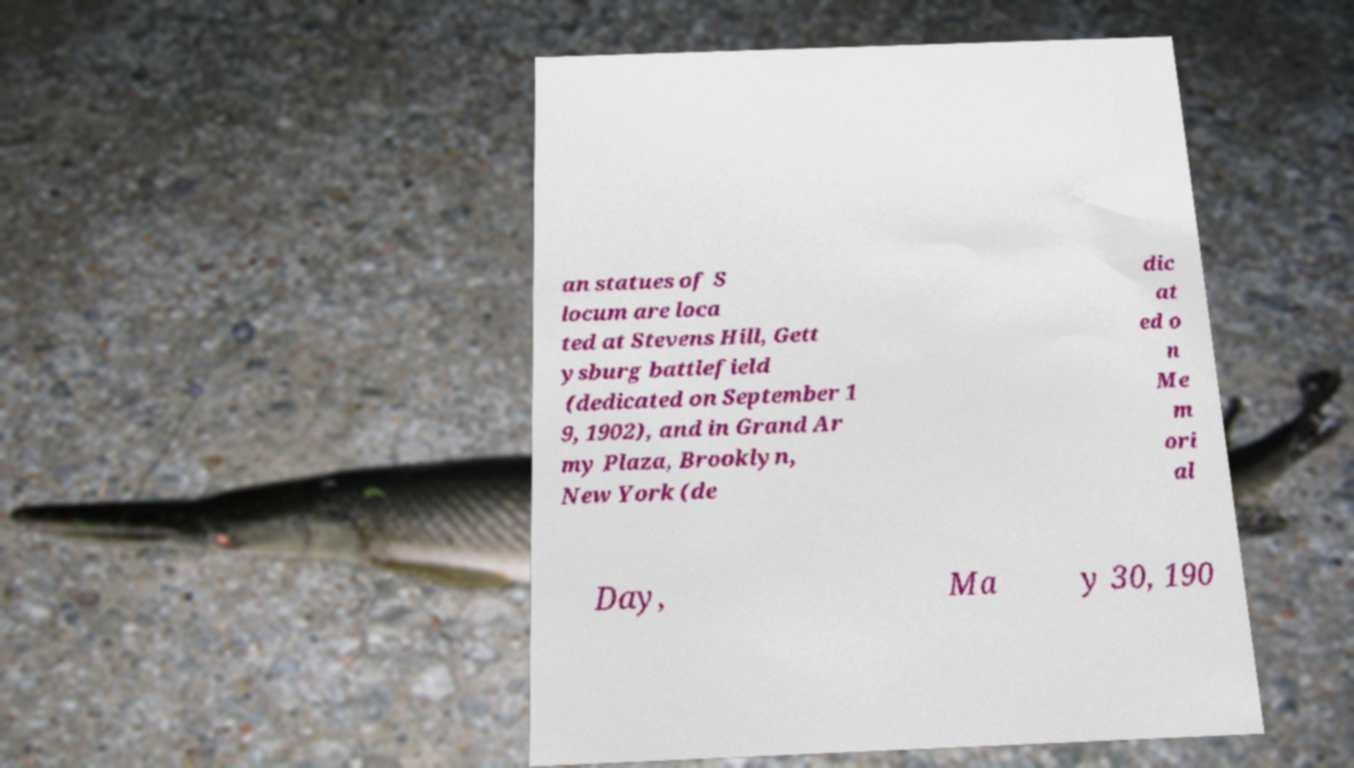Can you read and provide the text displayed in the image?This photo seems to have some interesting text. Can you extract and type it out for me? an statues of S locum are loca ted at Stevens Hill, Gett ysburg battlefield (dedicated on September 1 9, 1902), and in Grand Ar my Plaza, Brooklyn, New York (de dic at ed o n Me m ori al Day, Ma y 30, 190 